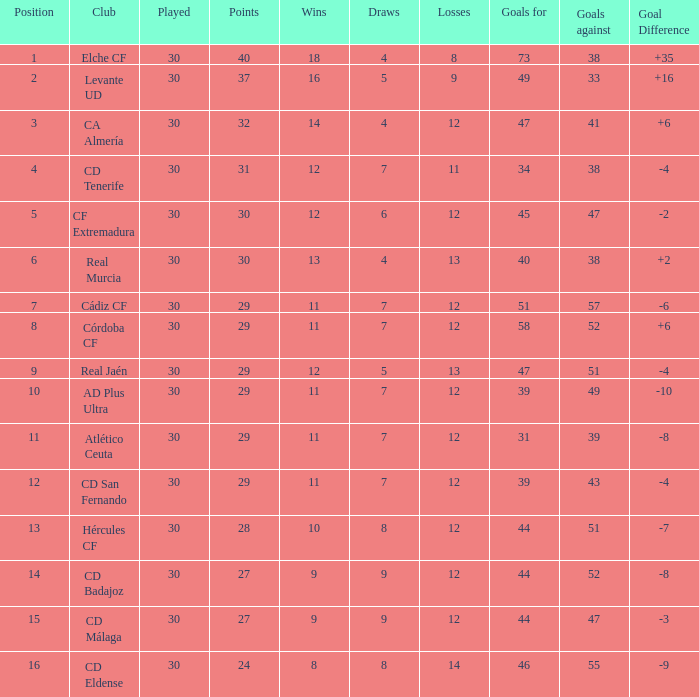What is the total of goals with less than 14 triumphs and a goal difference below -4? 51, 39, 31, 44, 44, 46. Parse the table in full. {'header': ['Position', 'Club', 'Played', 'Points', 'Wins', 'Draws', 'Losses', 'Goals for', 'Goals against', 'Goal Difference'], 'rows': [['1', 'Elche CF', '30', '40', '18', '4', '8', '73', '38', '+35'], ['2', 'Levante UD', '30', '37', '16', '5', '9', '49', '33', '+16'], ['3', 'CA Almería', '30', '32', '14', '4', '12', '47', '41', '+6'], ['4', 'CD Tenerife', '30', '31', '12', '7', '11', '34', '38', '-4'], ['5', 'CF Extremadura', '30', '30', '12', '6', '12', '45', '47', '-2'], ['6', 'Real Murcia', '30', '30', '13', '4', '13', '40', '38', '+2'], ['7', 'Cádiz CF', '30', '29', '11', '7', '12', '51', '57', '-6'], ['8', 'Córdoba CF', '30', '29', '11', '7', '12', '58', '52', '+6'], ['9', 'Real Jaén', '30', '29', '12', '5', '13', '47', '51', '-4'], ['10', 'AD Plus Ultra', '30', '29', '11', '7', '12', '39', '49', '-10'], ['11', 'Atlético Ceuta', '30', '29', '11', '7', '12', '31', '39', '-8'], ['12', 'CD San Fernando', '30', '29', '11', '7', '12', '39', '43', '-4'], ['13', 'Hércules CF', '30', '28', '10', '8', '12', '44', '51', '-7'], ['14', 'CD Badajoz', '30', '27', '9', '9', '12', '44', '52', '-8'], ['15', 'CD Málaga', '30', '27', '9', '9', '12', '44', '47', '-3'], ['16', 'CD Eldense', '30', '24', '8', '8', '14', '46', '55', '-9']]} 